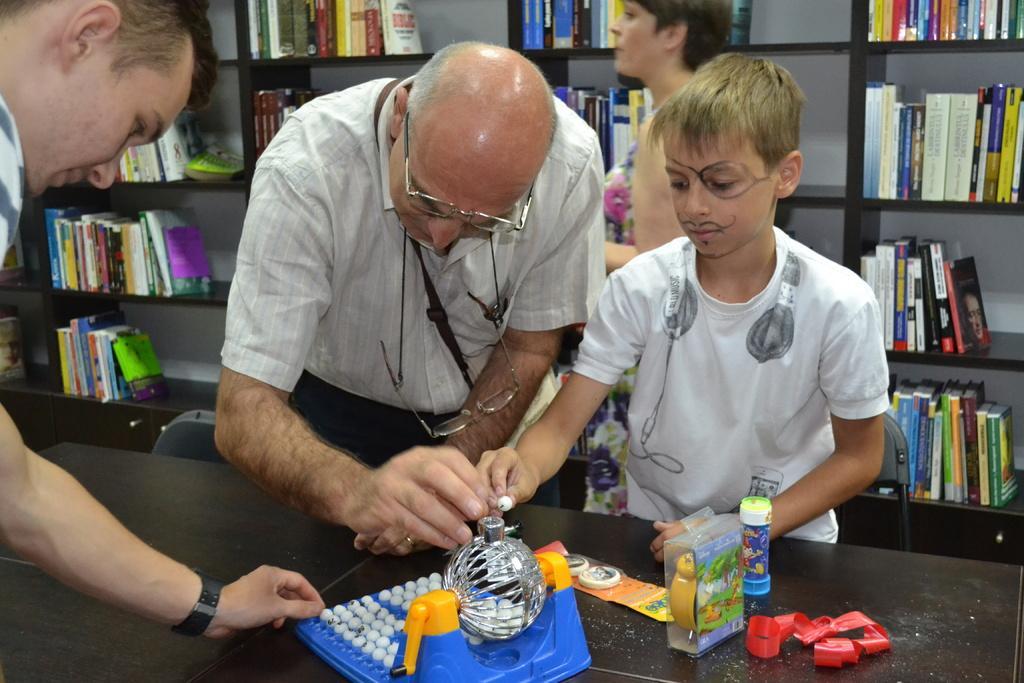Can you describe this image briefly? In this image I see 2 men, a boy and a woman over here and I see that these 3 of them are holding things in their hands and I see few things over here. In the background I see the books in these racks. 